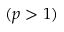<formula> <loc_0><loc_0><loc_500><loc_500>( p > 1 )</formula> 